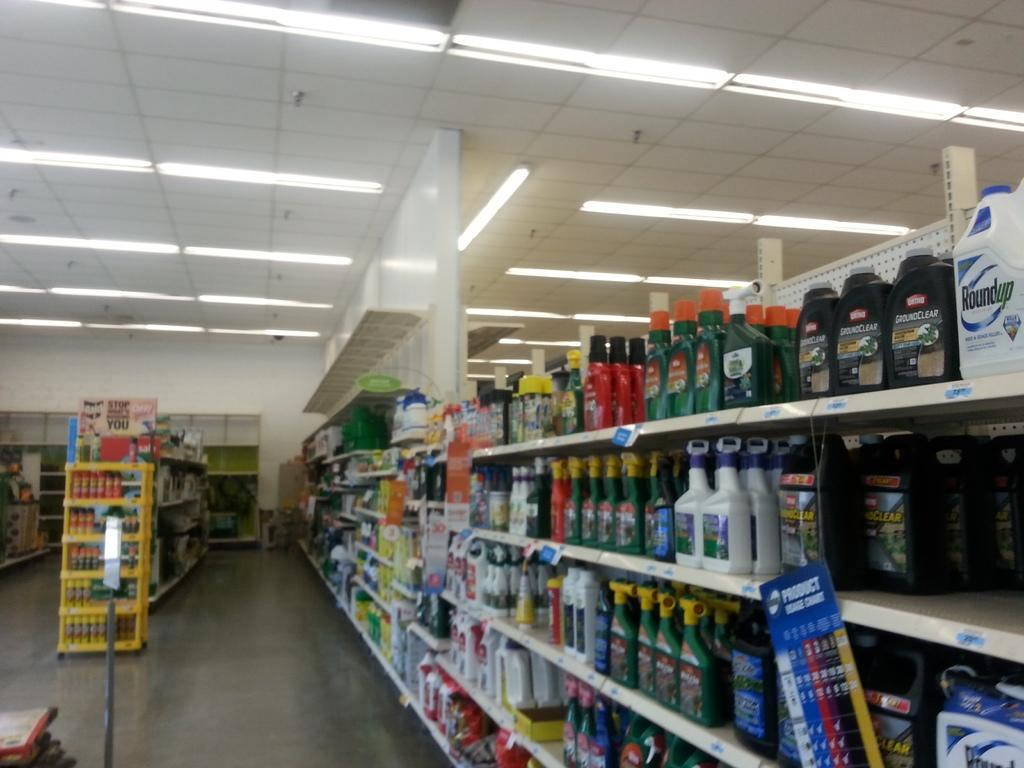<image>
Describe the image concisely. A store isle displays outdoor chemicals including Roundup. 